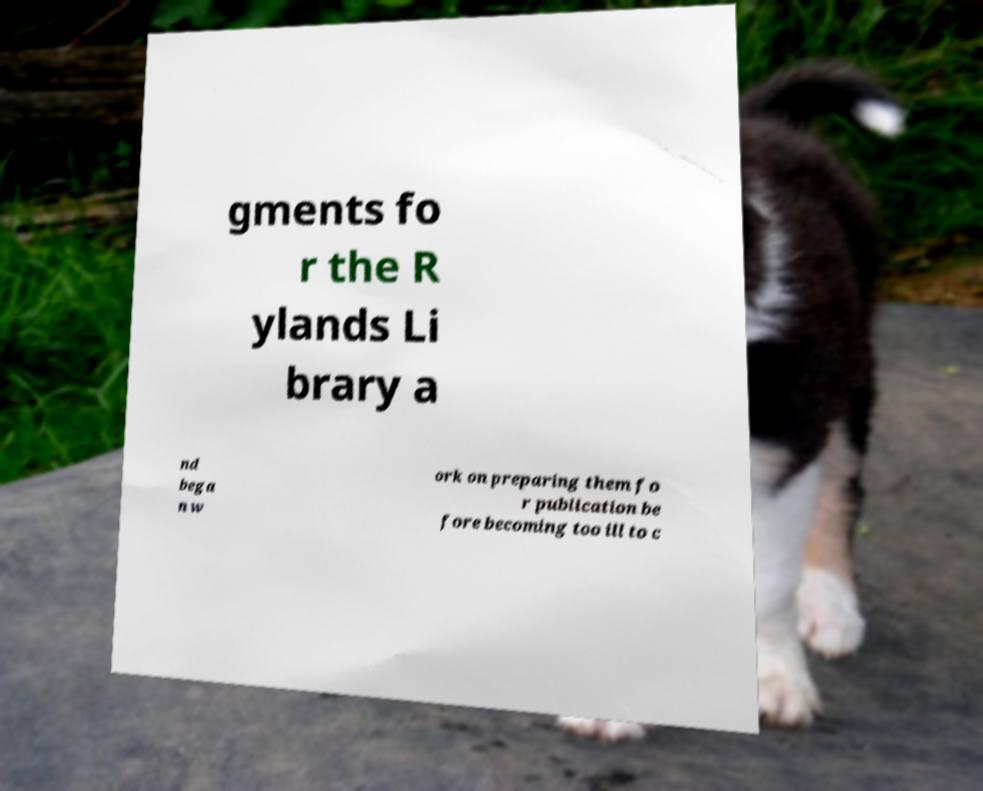Please read and relay the text visible in this image. What does it say? gments fo r the R ylands Li brary a nd bega n w ork on preparing them fo r publication be fore becoming too ill to c 